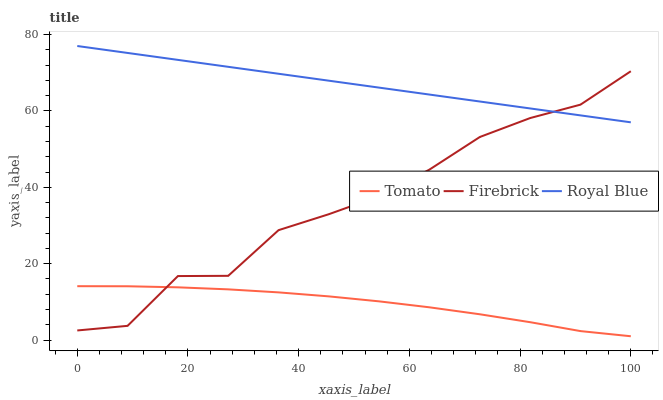Does Tomato have the minimum area under the curve?
Answer yes or no. Yes. Does Royal Blue have the maximum area under the curve?
Answer yes or no. Yes. Does Firebrick have the minimum area under the curve?
Answer yes or no. No. Does Firebrick have the maximum area under the curve?
Answer yes or no. No. Is Royal Blue the smoothest?
Answer yes or no. Yes. Is Firebrick the roughest?
Answer yes or no. Yes. Is Firebrick the smoothest?
Answer yes or no. No. Is Royal Blue the roughest?
Answer yes or no. No. Does Tomato have the lowest value?
Answer yes or no. Yes. Does Firebrick have the lowest value?
Answer yes or no. No. Does Royal Blue have the highest value?
Answer yes or no. Yes. Does Firebrick have the highest value?
Answer yes or no. No. Is Tomato less than Royal Blue?
Answer yes or no. Yes. Is Royal Blue greater than Tomato?
Answer yes or no. Yes. Does Firebrick intersect Royal Blue?
Answer yes or no. Yes. Is Firebrick less than Royal Blue?
Answer yes or no. No. Is Firebrick greater than Royal Blue?
Answer yes or no. No. Does Tomato intersect Royal Blue?
Answer yes or no. No. 